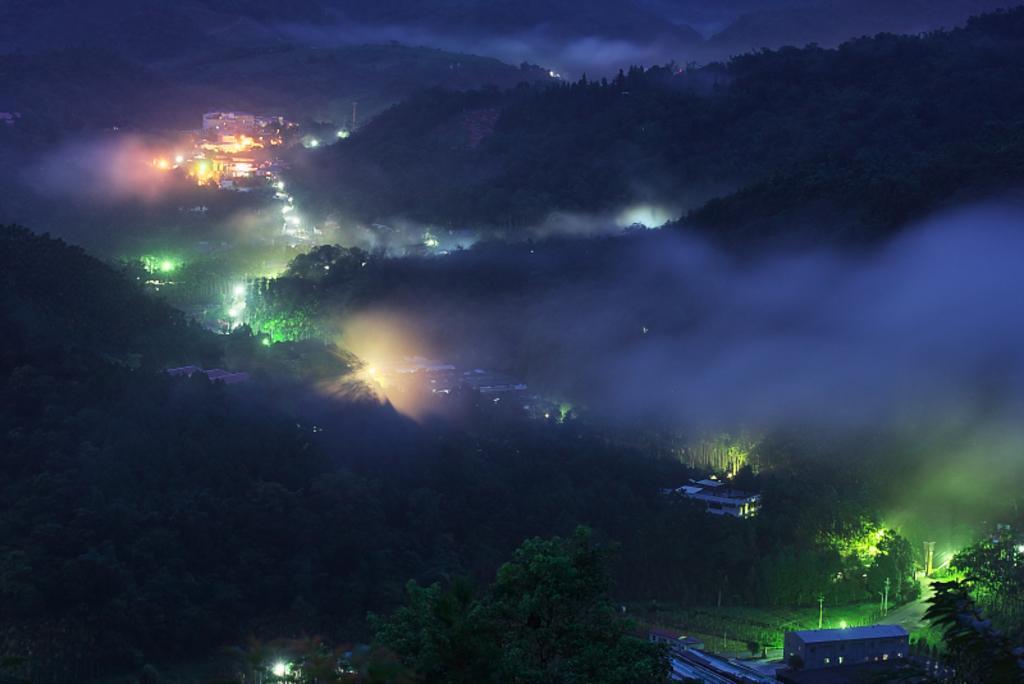Please provide a concise description of this image. In this image we can see a group of trees, some buildings, poles, lights, the hills and the sky which looks cloudy. 